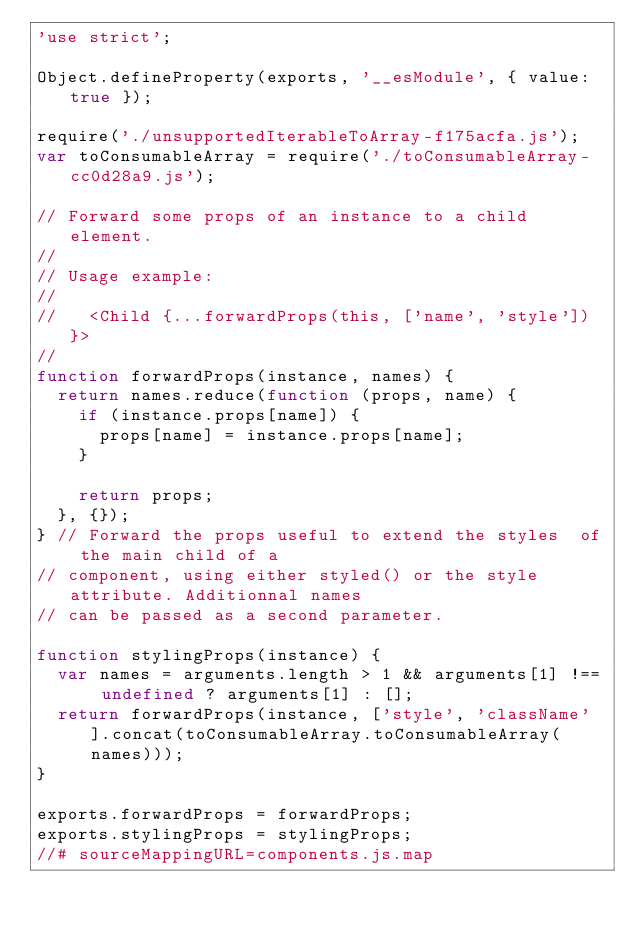<code> <loc_0><loc_0><loc_500><loc_500><_JavaScript_>'use strict';

Object.defineProperty(exports, '__esModule', { value: true });

require('./unsupportedIterableToArray-f175acfa.js');
var toConsumableArray = require('./toConsumableArray-cc0d28a9.js');

// Forward some props of an instance to a child element.
//
// Usage example:
//
//   <Child {...forwardProps(this, ['name', 'style'])}>
//
function forwardProps(instance, names) {
  return names.reduce(function (props, name) {
    if (instance.props[name]) {
      props[name] = instance.props[name];
    }

    return props;
  }, {});
} // Forward the props useful to extend the styles  of the main child of a
// component, using either styled() or the style attribute. Additionnal names
// can be passed as a second parameter.

function stylingProps(instance) {
  var names = arguments.length > 1 && arguments[1] !== undefined ? arguments[1] : [];
  return forwardProps(instance, ['style', 'className'].concat(toConsumableArray.toConsumableArray(names)));
}

exports.forwardProps = forwardProps;
exports.stylingProps = stylingProps;
//# sourceMappingURL=components.js.map
</code> 